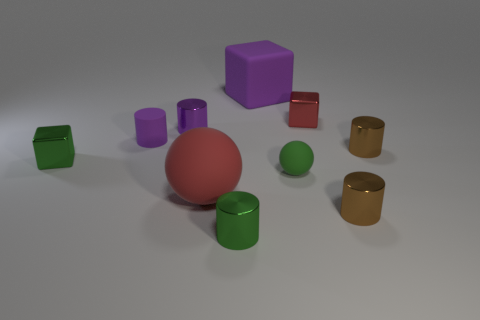What is the shape of the red object that is the same size as the green block?
Offer a terse response. Cube. Are there more objects than big blue rubber cylinders?
Give a very brief answer. Yes. What is the purple object that is both to the right of the tiny purple rubber cylinder and in front of the tiny red shiny object made of?
Keep it short and to the point. Metal. How many other things are there of the same material as the small green cylinder?
Give a very brief answer. 5. What number of large matte objects are the same color as the rubber cylinder?
Ensure brevity in your answer.  1. There is a shiny block to the right of the thing behind the tiny metal cube that is behind the tiny green block; what size is it?
Offer a very short reply. Small. What number of shiny objects are tiny red things or small brown cylinders?
Give a very brief answer. 3. There is a tiny green rubber object; does it have the same shape as the small brown thing in front of the small green rubber ball?
Ensure brevity in your answer.  No. Are there more large cubes that are in front of the red metallic block than small metallic things behind the green sphere?
Make the answer very short. No. Are there any other things of the same color as the tiny rubber sphere?
Keep it short and to the point. Yes. 